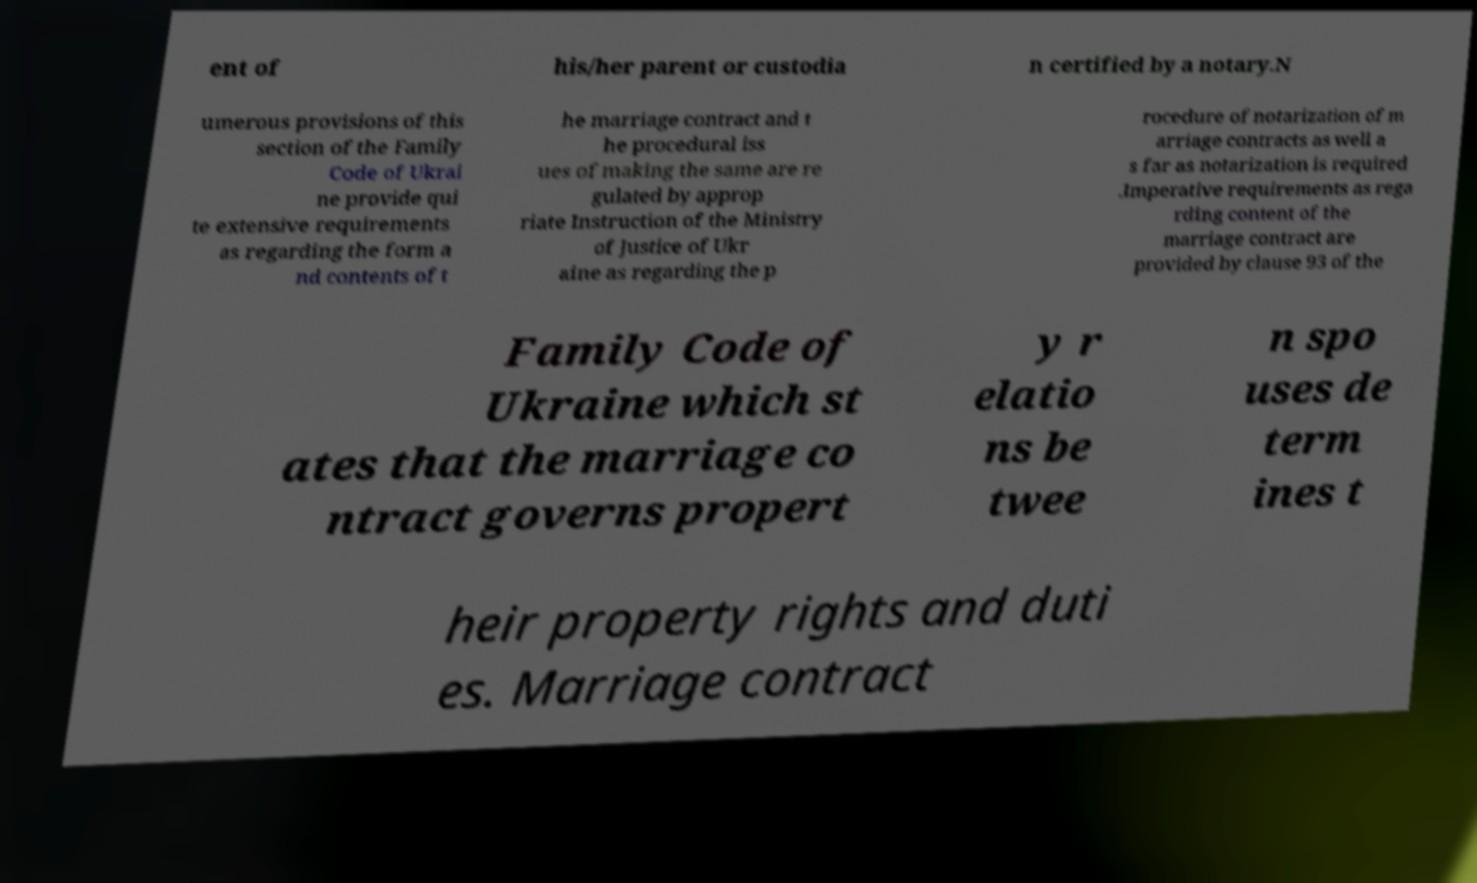There's text embedded in this image that I need extracted. Can you transcribe it verbatim? ent of his/her parent or custodia n certified by a notary.N umerous provisions of this section of the Family Code of Ukrai ne provide qui te extensive requirements as regarding the form a nd contents of t he marriage contract and t he procedural iss ues of making the same are re gulated by approp riate Instruction of the Ministry of Justice of Ukr aine as regarding the p rocedure of notarization of m arriage contracts as well a s far as notarization is required .Imperative requirements as rega rding content of the marriage contract are provided by clause 93 of the Family Code of Ukraine which st ates that the marriage co ntract governs propert y r elatio ns be twee n spo uses de term ines t heir property rights and duti es. Marriage contract 